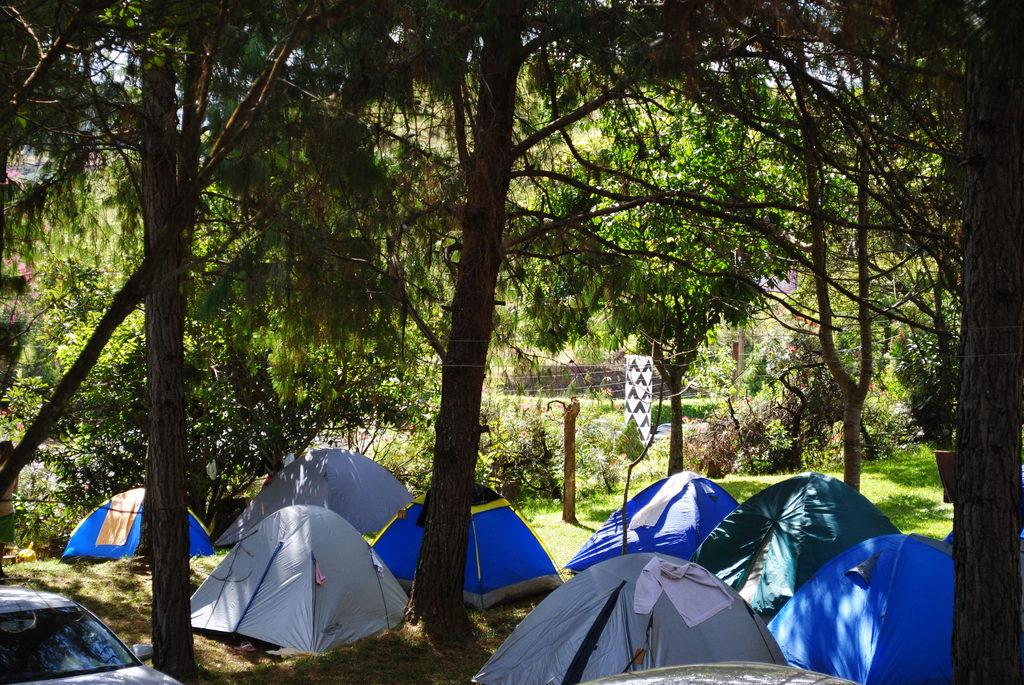What type of temporary shelter can be seen in the image? There are tents in the image. What mode of transportation is present in the image? There is a car in the image. What type of vegetation is visible in the image? There are trees in the image. What can be seen in the background of the image? There appears to be a building in the background of the image. What is visible in the sky in the image? The sky is visible in the image. How many wings can be seen on the trees in the image? Trees do not have wings; they have branches and leaves. What type of floor is visible in the image? The image does not show a floor; it shows tents, a car, trees, a building, and the sky. 